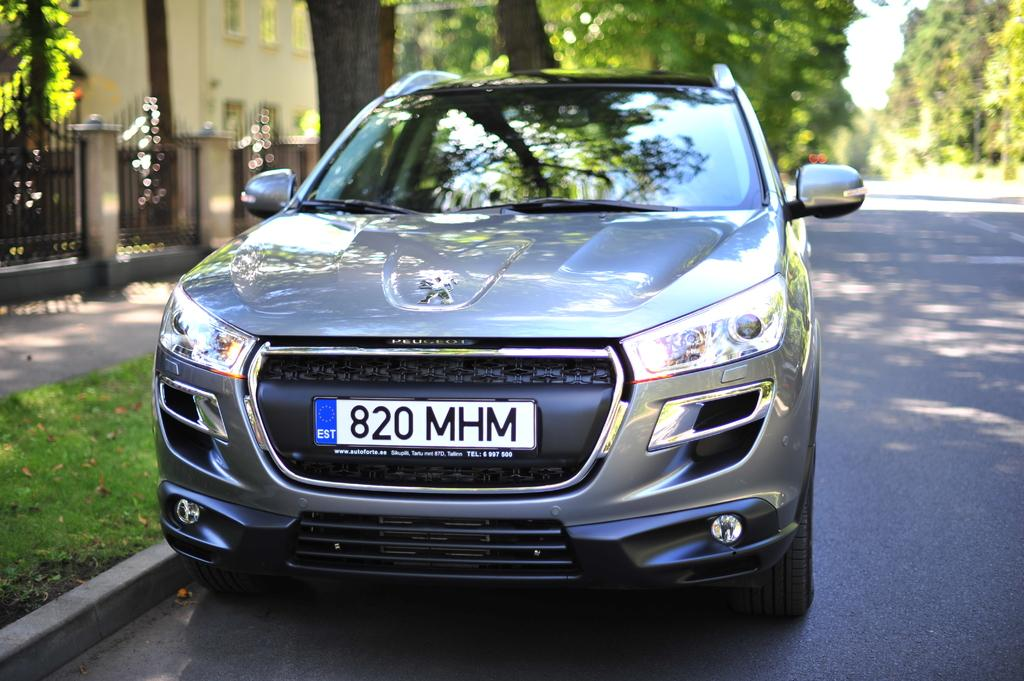What is the main subject of the image? There is a car on the road in the image. What can be seen beside the car? There is grass beside the car. What is visible in the background of the image? There is a fence, trees, and a building in the background of the image. What song is the car singing in the image? Cars do not sing songs, so this question cannot be answered. 